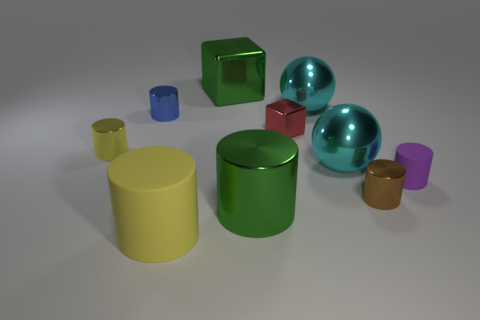Are there fewer blue shiny things that are right of the brown thing than big metallic balls that are on the left side of the red object?
Make the answer very short. No. How many gray objects are tiny spheres or shiny cylinders?
Your answer should be compact. 0. Are there an equal number of green things in front of the red shiny block and small matte cylinders?
Provide a succinct answer. Yes. How many objects are either green cubes or objects that are behind the yellow rubber cylinder?
Your answer should be very brief. 9. Do the small matte cylinder and the big shiny cylinder have the same color?
Make the answer very short. No. Is there another big green cylinder made of the same material as the large green cylinder?
Your answer should be very brief. No. What is the color of the tiny matte thing that is the same shape as the brown metal thing?
Offer a very short reply. Purple. Is the material of the red cube the same as the cube that is on the left side of the large green cylinder?
Offer a very short reply. Yes. The green thing that is behind the tiny shiny cylinder behind the red block is what shape?
Provide a succinct answer. Cube. There is a brown metal cylinder that is left of the purple cylinder; is it the same size as the purple cylinder?
Keep it short and to the point. Yes. 